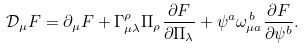<formula> <loc_0><loc_0><loc_500><loc_500>\mathcal { D } _ { \mu } F = \partial _ { \mu } F + \Gamma _ { \mu \lambda } ^ { \rho } \Pi _ { \rho } \frac { \partial F } { \partial \Pi _ { \lambda } } + \psi ^ { a } \omega _ { \mu a } ^ { \, b } \frac { \partial F } { \partial \psi ^ { b } } .</formula> 